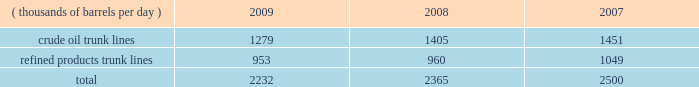Pipeline transportation 2013 we own a system of pipelines through marathon pipe line llc ( 201cmpl 201d ) and ohio river pipe line llc ( 201corpl 201d ) , our wholly-owned subsidiaries .
Our pipeline systems transport crude oil and refined products primarily in the midwest and gulf coast regions to our refineries , our terminals and other pipeline systems .
Our mpl and orpl wholly-owned and undivided interest common carrier systems consist of 1737 miles of crude oil lines and 1825 miles of refined product lines comprising 32 systems located in 11 states .
The mpl common carrier pipeline network is one of the largest petroleum pipeline systems in the united states , based on total barrels delivered .
Our common carrier pipeline systems are subject to state and federal energy regulatory commission regulations and guidelines , including published tariffs for the transportation of crude oil and refined products .
Third parties generated 13 percent of the crude oil and refined product shipments on our mpl and orpl common carrier pipelines in 2009 .
Our mpl and orpl common carrier pipelines transported the volumes shown in the table for each of the last three years .
Pipeline barrels handled ( thousands of barrels per day ) 2009 2008 2007 .
We also own 196 miles of private crude oil pipelines and 850 miles of private refined products pipelines , and we lease 217 miles of common carrier refined product pipelines .
We have partial ownership interests in several pipeline companies that have approximately 780 miles of crude oil pipelines and 3600 miles of refined products pipelines , including about 970 miles operated by mpl .
In addition , mpl operates most of our private pipelines and 985 miles of crude oil and 160 miles of natural gas pipelines owned by our e&p segment .
Our major refined product pipelines include the owned and operated cardinal products pipeline and the wabash pipeline .
The cardinal products pipeline delivers refined products from kenova , west virginia , to columbus , ohio .
The wabash pipeline system delivers product from robinson , illinois , to various terminals in the area of chicago , illinois .
Other significant refined product pipelines owned and operated by mpl extend from : robinson , illinois , to louisville , kentucky ; garyville , louisiana , to zachary , louisiana ; and texas city , texas , to pasadena , texas .
In addition , as of december 31 , 2009 , we had interests in the following refined product pipelines : 2022 65 percent undivided ownership interest in the louisville-lexington system , a petroleum products pipeline system extending from louisville to lexington , kentucky ; 2022 60 percent interest in muskegon pipeline llc , which owns a refined products pipeline extending from griffith , indiana , to north muskegon , michigan ; 2022 50 percent interest in centennial pipeline llc , which owns a refined products system connecting the gulf coast region with the midwest market ; 2022 17 percent interest in explorer pipeline company , a refined products pipeline system extending from the gulf coast to the midwest ; and 2022 6 percent interest in wolverine pipe line company , a refined products pipeline system extending from chicago , illinois , to toledo , ohio .
Our major owned and operated crude oil lines run from : patoka , illinois , to catlettsburg , kentucky ; patoka , illinois , to robinson , illinois ; patoka , illinois , to lima , ohio ; lima , ohio to canton , ohio ; samaria , michigan , to detroit , michigan ; and st .
James , louisiana , to garyville , louisiana .
As of december 31 , 2009 , we had interests in the following crude oil pipelines : 2022 51 percent interest in loop llc , the owner and operator of loop , which is the only u.s .
Deepwater oil port , located 18 miles off the coast of louisiana , and a crude oil pipeline connecting the port facility to storage caverns and tanks at clovelly , louisiana ; 2022 59 percent interest in locap llc , which owns a crude oil pipeline connecting loop and the capline system; .
What was the percentage decline in pipeline barrels from 2007 to 2009? 
Computations: ((2500 - 2232) / 2500)
Answer: 0.1072. 